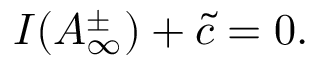<formula> <loc_0><loc_0><loc_500><loc_500>I ( A _ { \infty } ^ { \pm } ) + \tilde { c } = 0 .</formula> 